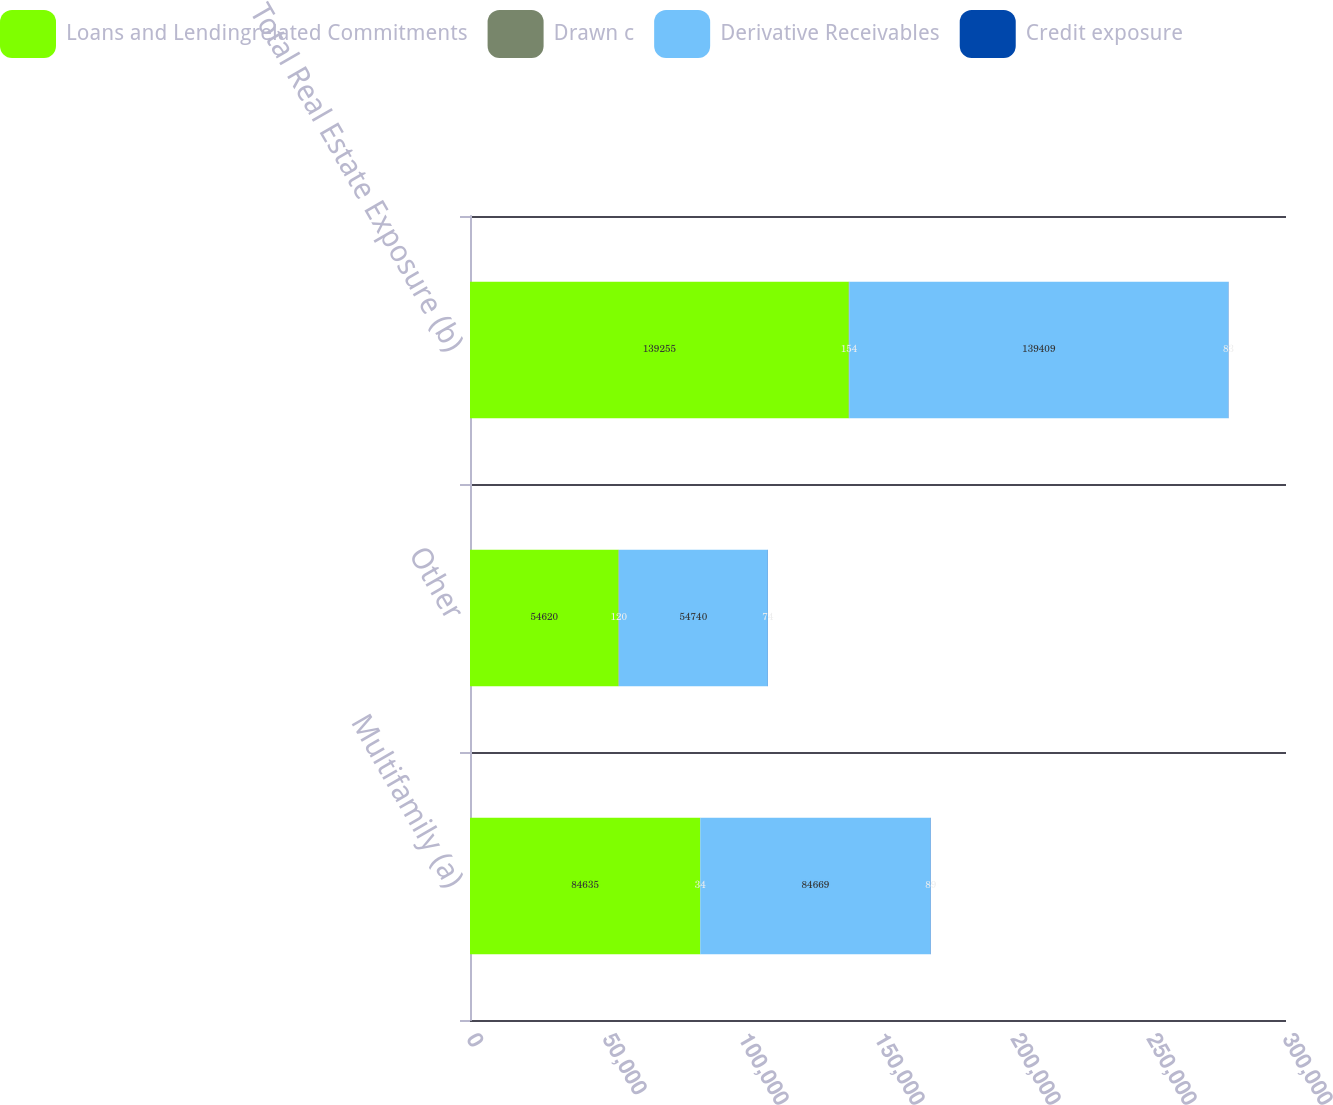Convert chart to OTSL. <chart><loc_0><loc_0><loc_500><loc_500><stacked_bar_chart><ecel><fcel>Multifamily (a)<fcel>Other<fcel>Total Real Estate Exposure (b)<nl><fcel>Loans and Lendingrelated Commitments<fcel>84635<fcel>54620<fcel>139255<nl><fcel>Drawn c<fcel>34<fcel>120<fcel>154<nl><fcel>Derivative Receivables<fcel>84669<fcel>54740<fcel>139409<nl><fcel>Credit exposure<fcel>89<fcel>74<fcel>83<nl></chart> 